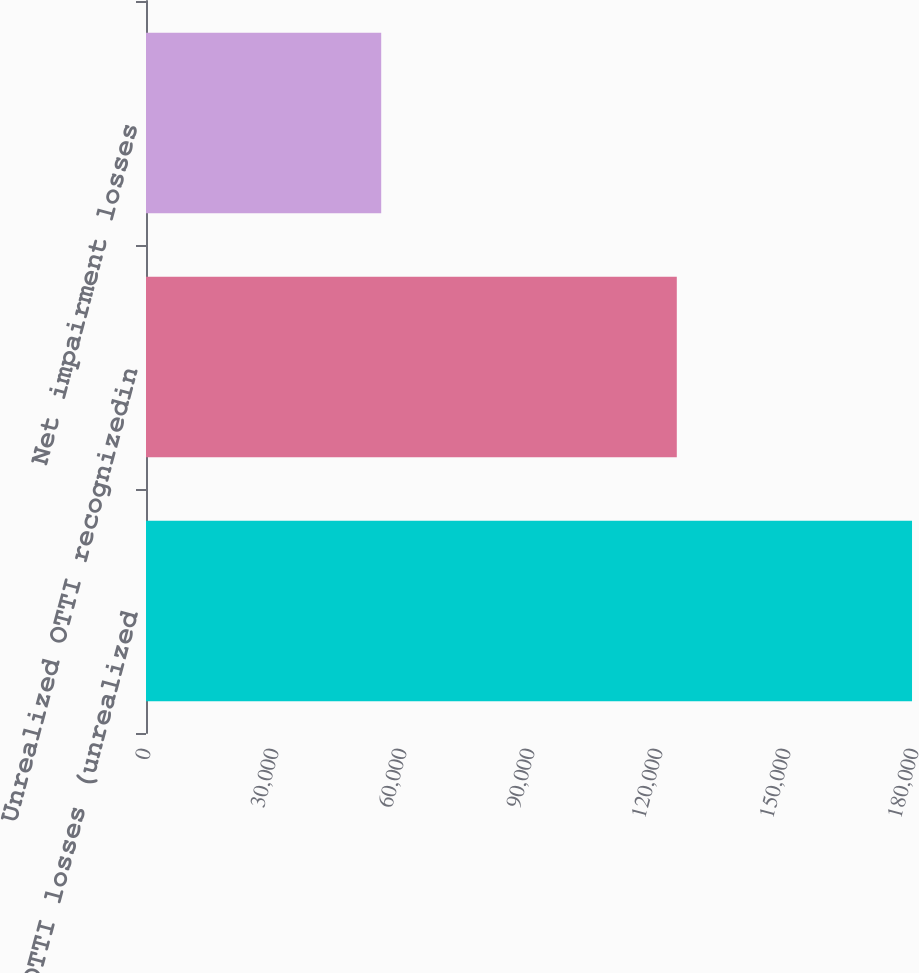<chart> <loc_0><loc_0><loc_500><loc_500><bar_chart><fcel>Total OTTI losses (unrealized<fcel>Unrealized OTTI recognizedin<fcel>Net impairment losses<nl><fcel>179535<fcel>124408<fcel>55127<nl></chart> 